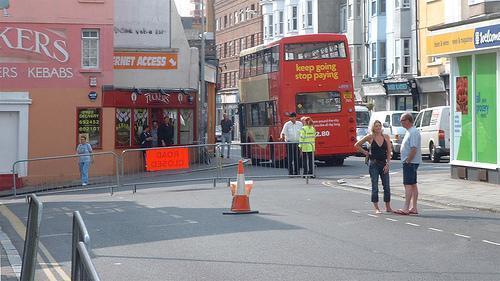How many buses are in the photo?
Give a very brief answer. 1. How many traffic cones do you see?
Give a very brief answer. 1. How many of the kites are shaped like an iguana?
Give a very brief answer. 0. 